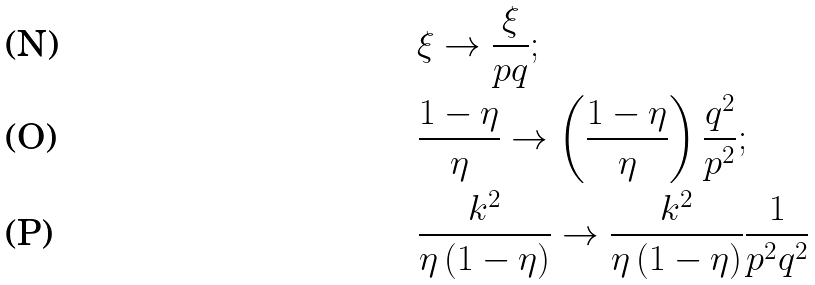<formula> <loc_0><loc_0><loc_500><loc_500>& \xi \rightarrow \frac { \xi } { p q } ; \\ & \frac { 1 - \eta } { \eta } \rightarrow \left ( \frac { 1 - \eta } { \eta } \right ) \frac { q ^ { 2 } } { p ^ { 2 } } ; \\ & \frac { k ^ { 2 } } { \eta \left ( 1 - \eta \right ) } \rightarrow \frac { k ^ { 2 } } { \eta \left ( 1 - \eta \right ) } \frac { 1 } { p ^ { 2 } q ^ { 2 } }</formula> 